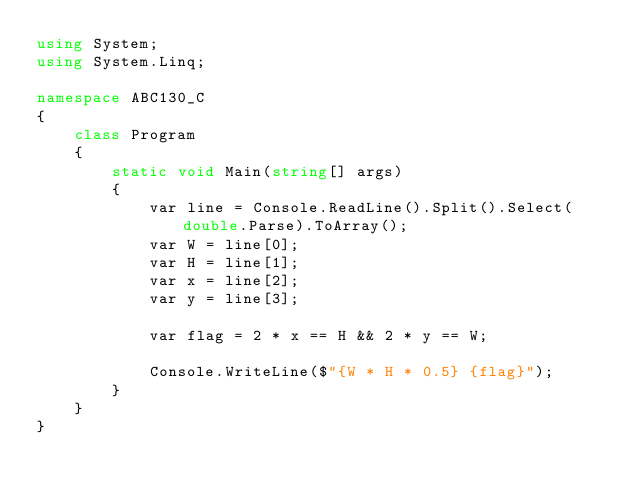<code> <loc_0><loc_0><loc_500><loc_500><_C#_>using System;
using System.Linq;

namespace ABC130_C
{
    class Program
    {
        static void Main(string[] args)
        {
            var line = Console.ReadLine().Split().Select(double.Parse).ToArray();
            var W = line[0];
            var H = line[1];
            var x = line[2];
            var y = line[3];

            var flag = 2 * x == H && 2 * y == W;

            Console.WriteLine($"{W * H * 0.5} {flag}");
        }
    }
}
</code> 